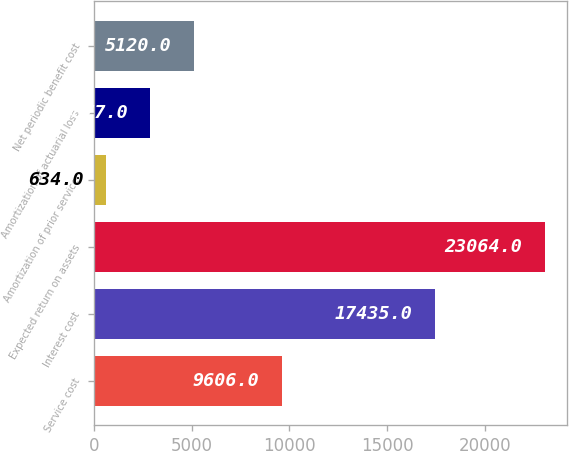Convert chart to OTSL. <chart><loc_0><loc_0><loc_500><loc_500><bar_chart><fcel>Service cost<fcel>Interest cost<fcel>Expected return on assets<fcel>Amortization of prior service<fcel>Amortization of actuarial loss<fcel>Net periodic benefit cost<nl><fcel>9606<fcel>17435<fcel>23064<fcel>634<fcel>2877<fcel>5120<nl></chart> 